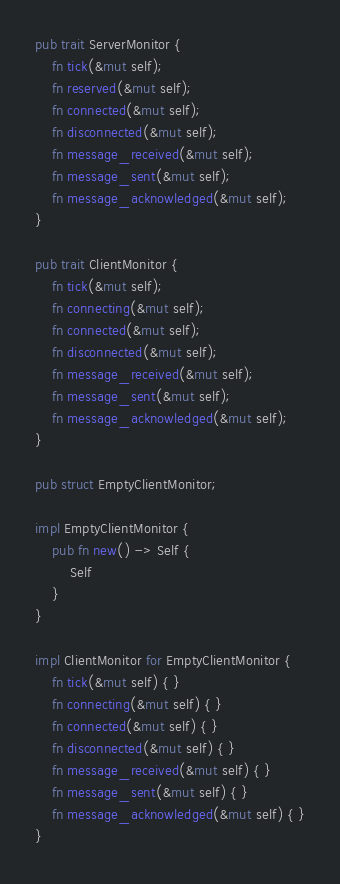Convert code to text. <code><loc_0><loc_0><loc_500><loc_500><_Rust_>pub trait ServerMonitor {
    fn tick(&mut self);
    fn reserved(&mut self);
    fn connected(&mut self);
    fn disconnected(&mut self);
    fn message_received(&mut self);
    fn message_sent(&mut self);
    fn message_acknowledged(&mut self);
}

pub trait ClientMonitor {
    fn tick(&mut self);
    fn connecting(&mut self);
    fn connected(&mut self);
    fn disconnected(&mut self);
    fn message_received(&mut self);
    fn message_sent(&mut self);
    fn message_acknowledged(&mut self);
}

pub struct EmptyClientMonitor;

impl EmptyClientMonitor {
    pub fn new() -> Self {
        Self
    }
}

impl ClientMonitor for EmptyClientMonitor {
    fn tick(&mut self) { }
    fn connecting(&mut self) { }
    fn connected(&mut self) { }
    fn disconnected(&mut self) { }
    fn message_received(&mut self) { }
    fn message_sent(&mut self) { }
    fn message_acknowledged(&mut self) { }
}
</code> 